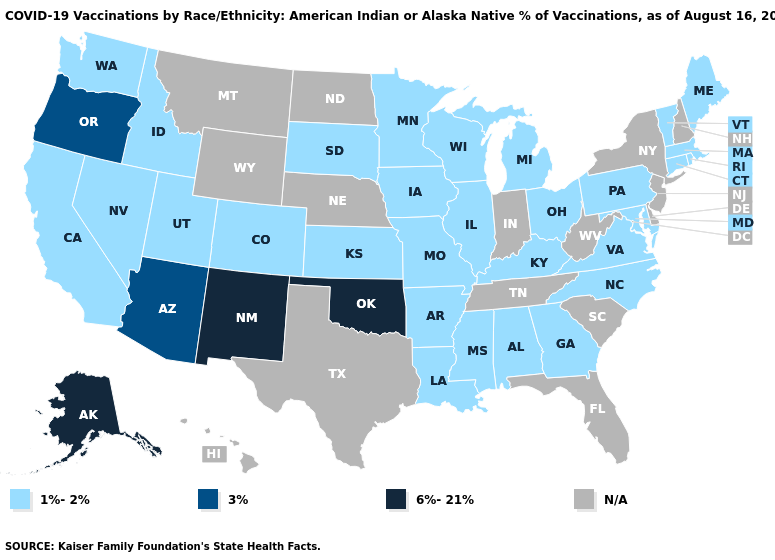How many symbols are there in the legend?
Quick response, please. 4. What is the lowest value in the USA?
Keep it brief. 1%-2%. What is the highest value in the USA?
Be succinct. 6%-21%. What is the highest value in states that border Florida?
Write a very short answer. 1%-2%. Name the states that have a value in the range N/A?
Keep it brief. Delaware, Florida, Hawaii, Indiana, Montana, Nebraska, New Hampshire, New Jersey, New York, North Dakota, South Carolina, Tennessee, Texas, West Virginia, Wyoming. What is the highest value in states that border Alabama?
Write a very short answer. 1%-2%. Is the legend a continuous bar?
Be succinct. No. What is the value of Oklahoma?
Quick response, please. 6%-21%. What is the value of Kentucky?
Short answer required. 1%-2%. Does Kansas have the lowest value in the USA?
Write a very short answer. Yes. Does Maine have the highest value in the USA?
Quick response, please. No. Which states have the highest value in the USA?
Write a very short answer. Alaska, New Mexico, Oklahoma. Among the states that border West Virginia , which have the lowest value?
Keep it brief. Kentucky, Maryland, Ohio, Pennsylvania, Virginia. 